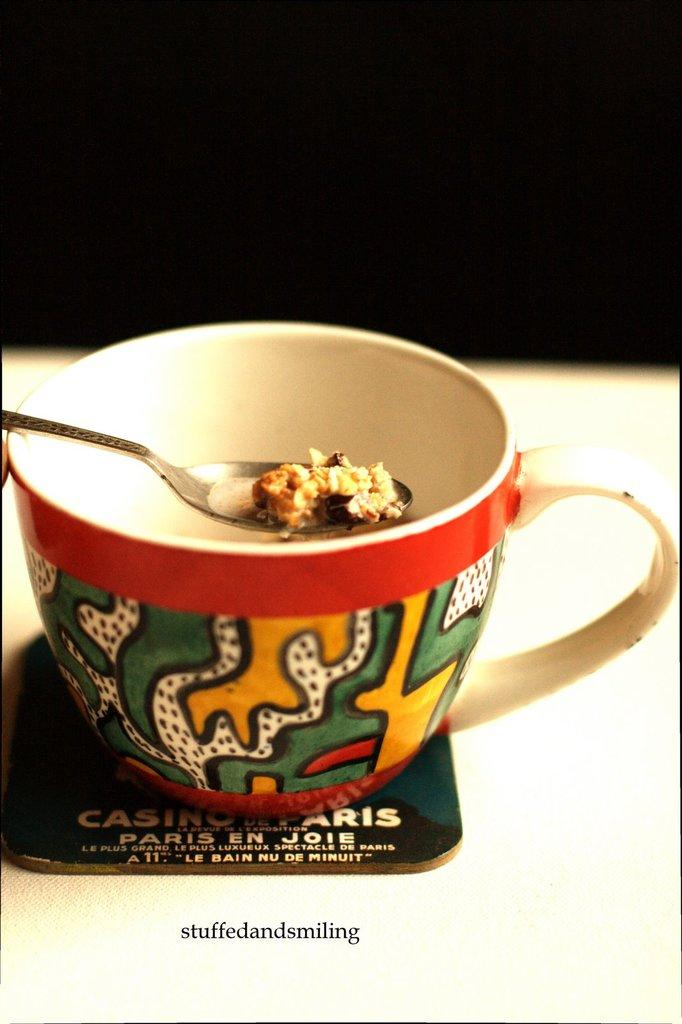What is present in the image that can be used for holding liquids? There is a cup in the image that can be used for holding liquids. What is being held by the spoon in the image? The spoon in the image contains food. What object can be seen on the table in the image? There is a card placed on the table in the image. How many cattle are visible in the image? There are no cattle present in the image. What type of fuel is being used by the card in the image? The card in the image is not using any fuel, as it is a stationary object. 